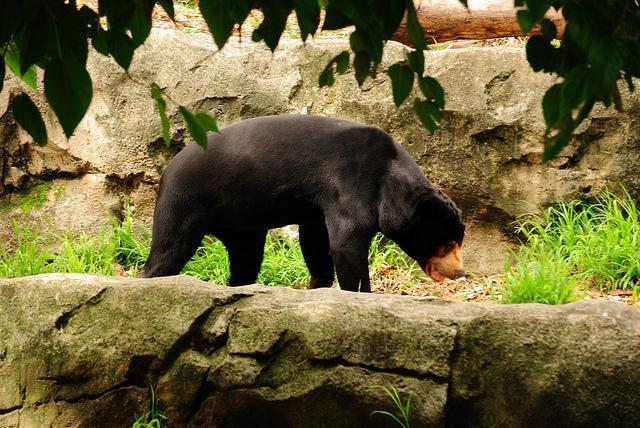How many tufts of grass are below the bear?
Give a very brief answer. 2. 